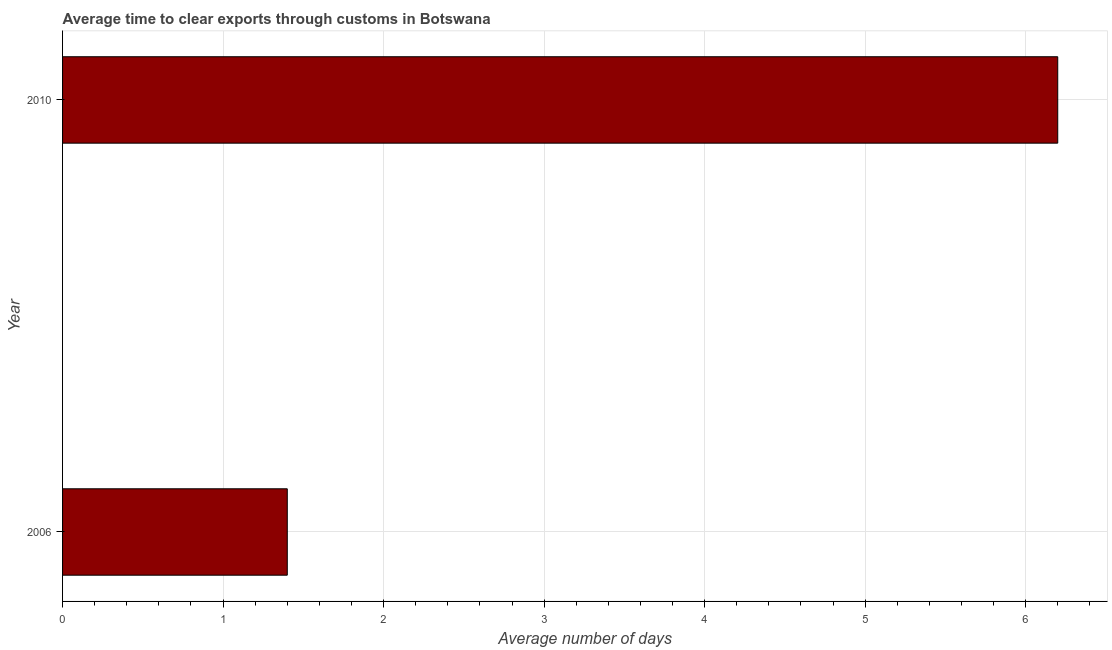Does the graph contain any zero values?
Your answer should be compact. No. Does the graph contain grids?
Keep it short and to the point. Yes. What is the title of the graph?
Give a very brief answer. Average time to clear exports through customs in Botswana. What is the label or title of the X-axis?
Ensure brevity in your answer.  Average number of days. What is the time to clear exports through customs in 2006?
Provide a short and direct response. 1.4. Across all years, what is the maximum time to clear exports through customs?
Your answer should be very brief. 6.2. What is the median time to clear exports through customs?
Provide a short and direct response. 3.8. What is the ratio of the time to clear exports through customs in 2006 to that in 2010?
Make the answer very short. 0.23. How many bars are there?
Provide a short and direct response. 2. Are all the bars in the graph horizontal?
Give a very brief answer. Yes. What is the difference between two consecutive major ticks on the X-axis?
Make the answer very short. 1. Are the values on the major ticks of X-axis written in scientific E-notation?
Offer a very short reply. No. What is the Average number of days of 2006?
Provide a short and direct response. 1.4. What is the ratio of the Average number of days in 2006 to that in 2010?
Provide a short and direct response. 0.23. 